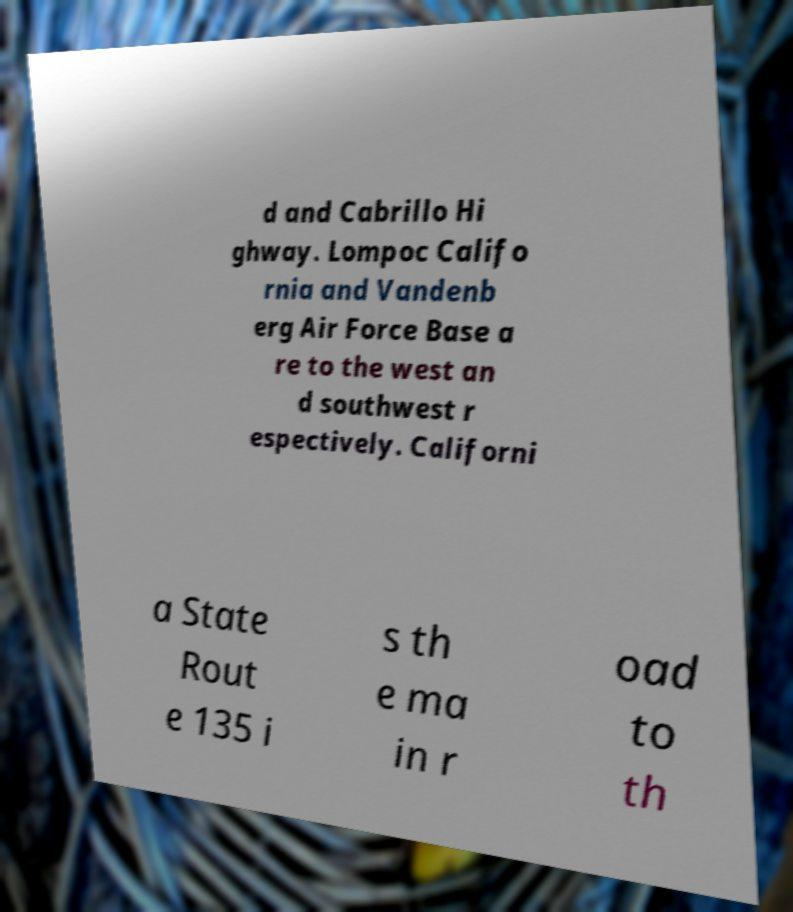What messages or text are displayed in this image? I need them in a readable, typed format. d and Cabrillo Hi ghway. Lompoc Califo rnia and Vandenb erg Air Force Base a re to the west an d southwest r espectively. Californi a State Rout e 135 i s th e ma in r oad to th 